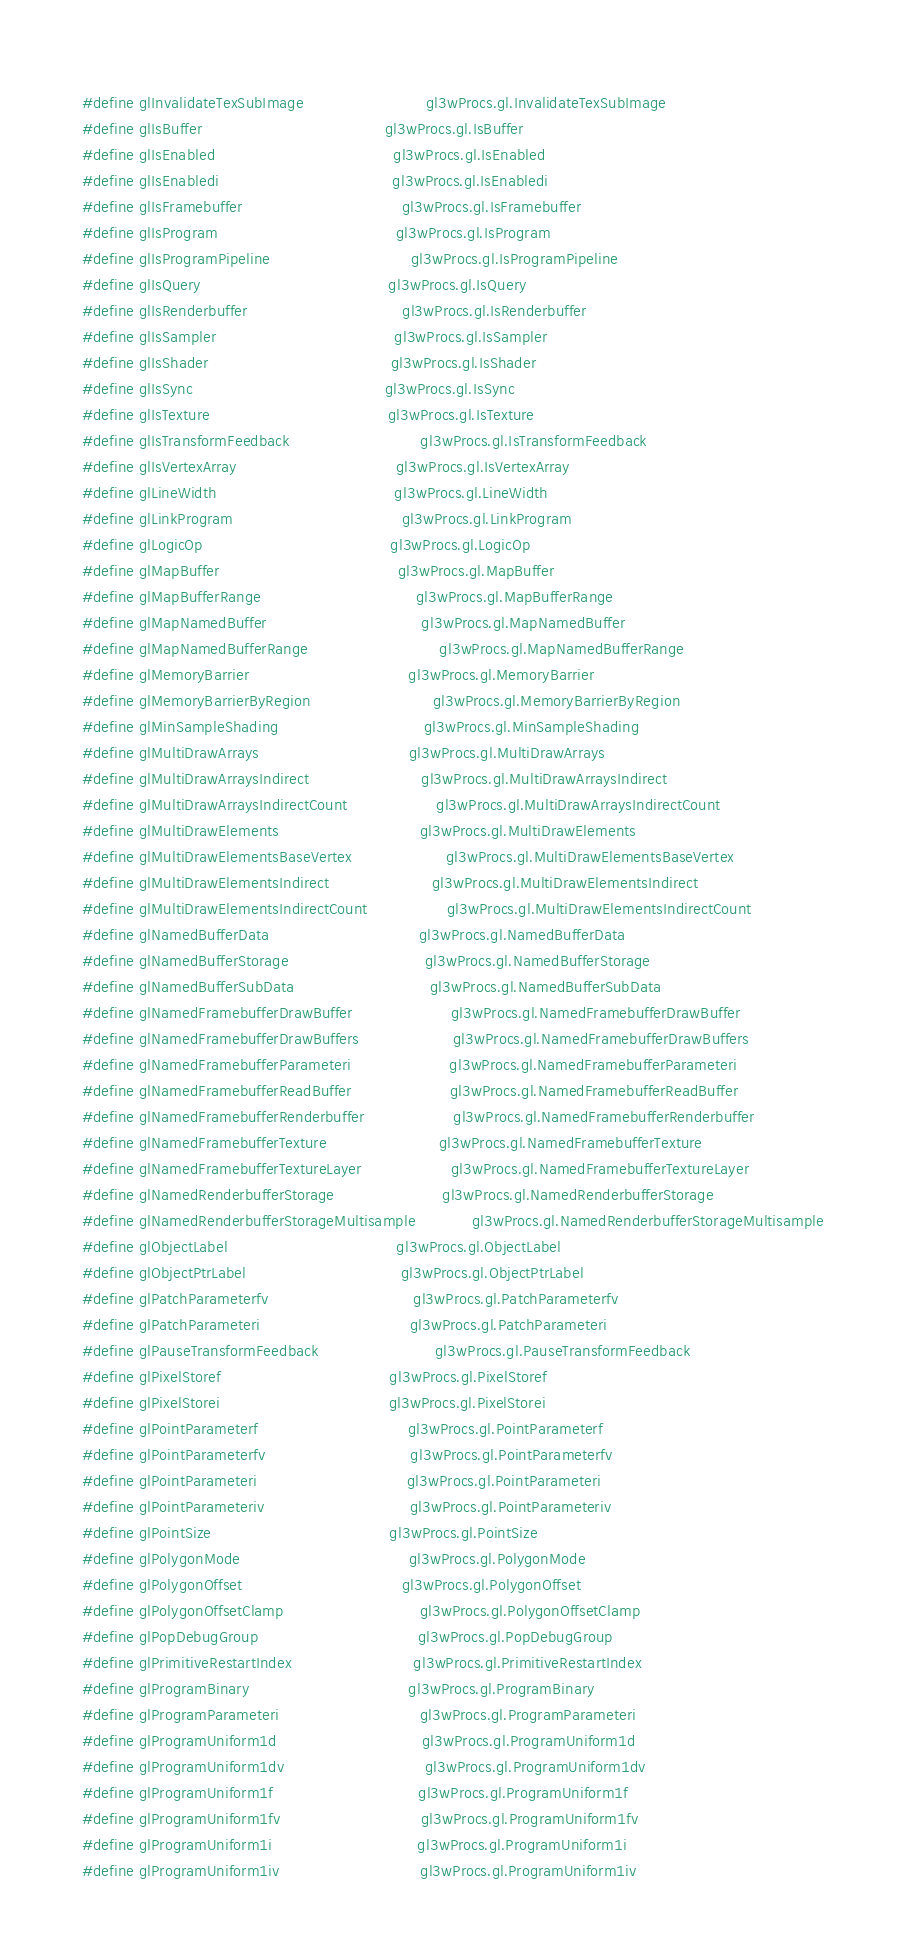<code> <loc_0><loc_0><loc_500><loc_500><_C_>#define glInvalidateTexSubImage                          gl3wProcs.gl.InvalidateTexSubImage
#define glIsBuffer                                       gl3wProcs.gl.IsBuffer
#define glIsEnabled                                      gl3wProcs.gl.IsEnabled
#define glIsEnabledi                                     gl3wProcs.gl.IsEnabledi
#define glIsFramebuffer                                  gl3wProcs.gl.IsFramebuffer
#define glIsProgram                                      gl3wProcs.gl.IsProgram
#define glIsProgramPipeline                              gl3wProcs.gl.IsProgramPipeline
#define glIsQuery                                        gl3wProcs.gl.IsQuery
#define glIsRenderbuffer                                 gl3wProcs.gl.IsRenderbuffer
#define glIsSampler                                      gl3wProcs.gl.IsSampler
#define glIsShader                                       gl3wProcs.gl.IsShader
#define glIsSync                                         gl3wProcs.gl.IsSync
#define glIsTexture                                      gl3wProcs.gl.IsTexture
#define glIsTransformFeedback                            gl3wProcs.gl.IsTransformFeedback
#define glIsVertexArray                                  gl3wProcs.gl.IsVertexArray
#define glLineWidth                                      gl3wProcs.gl.LineWidth
#define glLinkProgram                                    gl3wProcs.gl.LinkProgram
#define glLogicOp                                        gl3wProcs.gl.LogicOp
#define glMapBuffer                                      gl3wProcs.gl.MapBuffer
#define glMapBufferRange                                 gl3wProcs.gl.MapBufferRange
#define glMapNamedBuffer                                 gl3wProcs.gl.MapNamedBuffer
#define glMapNamedBufferRange                            gl3wProcs.gl.MapNamedBufferRange
#define glMemoryBarrier                                  gl3wProcs.gl.MemoryBarrier
#define glMemoryBarrierByRegion                          gl3wProcs.gl.MemoryBarrierByRegion
#define glMinSampleShading                               gl3wProcs.gl.MinSampleShading
#define glMultiDrawArrays                                gl3wProcs.gl.MultiDrawArrays
#define glMultiDrawArraysIndirect                        gl3wProcs.gl.MultiDrawArraysIndirect
#define glMultiDrawArraysIndirectCount                   gl3wProcs.gl.MultiDrawArraysIndirectCount
#define glMultiDrawElements                              gl3wProcs.gl.MultiDrawElements
#define glMultiDrawElementsBaseVertex                    gl3wProcs.gl.MultiDrawElementsBaseVertex
#define glMultiDrawElementsIndirect                      gl3wProcs.gl.MultiDrawElementsIndirect
#define glMultiDrawElementsIndirectCount                 gl3wProcs.gl.MultiDrawElementsIndirectCount
#define glNamedBufferData                                gl3wProcs.gl.NamedBufferData
#define glNamedBufferStorage                             gl3wProcs.gl.NamedBufferStorage
#define glNamedBufferSubData                             gl3wProcs.gl.NamedBufferSubData
#define glNamedFramebufferDrawBuffer                     gl3wProcs.gl.NamedFramebufferDrawBuffer
#define glNamedFramebufferDrawBuffers                    gl3wProcs.gl.NamedFramebufferDrawBuffers
#define glNamedFramebufferParameteri                     gl3wProcs.gl.NamedFramebufferParameteri
#define glNamedFramebufferReadBuffer                     gl3wProcs.gl.NamedFramebufferReadBuffer
#define glNamedFramebufferRenderbuffer                   gl3wProcs.gl.NamedFramebufferRenderbuffer
#define glNamedFramebufferTexture                        gl3wProcs.gl.NamedFramebufferTexture
#define glNamedFramebufferTextureLayer                   gl3wProcs.gl.NamedFramebufferTextureLayer
#define glNamedRenderbufferStorage                       gl3wProcs.gl.NamedRenderbufferStorage
#define glNamedRenderbufferStorageMultisample            gl3wProcs.gl.NamedRenderbufferStorageMultisample
#define glObjectLabel                                    gl3wProcs.gl.ObjectLabel
#define glObjectPtrLabel                                 gl3wProcs.gl.ObjectPtrLabel
#define glPatchParameterfv                               gl3wProcs.gl.PatchParameterfv
#define glPatchParameteri                                gl3wProcs.gl.PatchParameteri
#define glPauseTransformFeedback                         gl3wProcs.gl.PauseTransformFeedback
#define glPixelStoref                                    gl3wProcs.gl.PixelStoref
#define glPixelStorei                                    gl3wProcs.gl.PixelStorei
#define glPointParameterf                                gl3wProcs.gl.PointParameterf
#define glPointParameterfv                               gl3wProcs.gl.PointParameterfv
#define glPointParameteri                                gl3wProcs.gl.PointParameteri
#define glPointParameteriv                               gl3wProcs.gl.PointParameteriv
#define glPointSize                                      gl3wProcs.gl.PointSize
#define glPolygonMode                                    gl3wProcs.gl.PolygonMode
#define glPolygonOffset                                  gl3wProcs.gl.PolygonOffset
#define glPolygonOffsetClamp                             gl3wProcs.gl.PolygonOffsetClamp
#define glPopDebugGroup                                  gl3wProcs.gl.PopDebugGroup
#define glPrimitiveRestartIndex                          gl3wProcs.gl.PrimitiveRestartIndex
#define glProgramBinary                                  gl3wProcs.gl.ProgramBinary
#define glProgramParameteri                              gl3wProcs.gl.ProgramParameteri
#define glProgramUniform1d                               gl3wProcs.gl.ProgramUniform1d
#define glProgramUniform1dv                              gl3wProcs.gl.ProgramUniform1dv
#define glProgramUniform1f                               gl3wProcs.gl.ProgramUniform1f
#define glProgramUniform1fv                              gl3wProcs.gl.ProgramUniform1fv
#define glProgramUniform1i                               gl3wProcs.gl.ProgramUniform1i
#define glProgramUniform1iv                              gl3wProcs.gl.ProgramUniform1iv</code> 